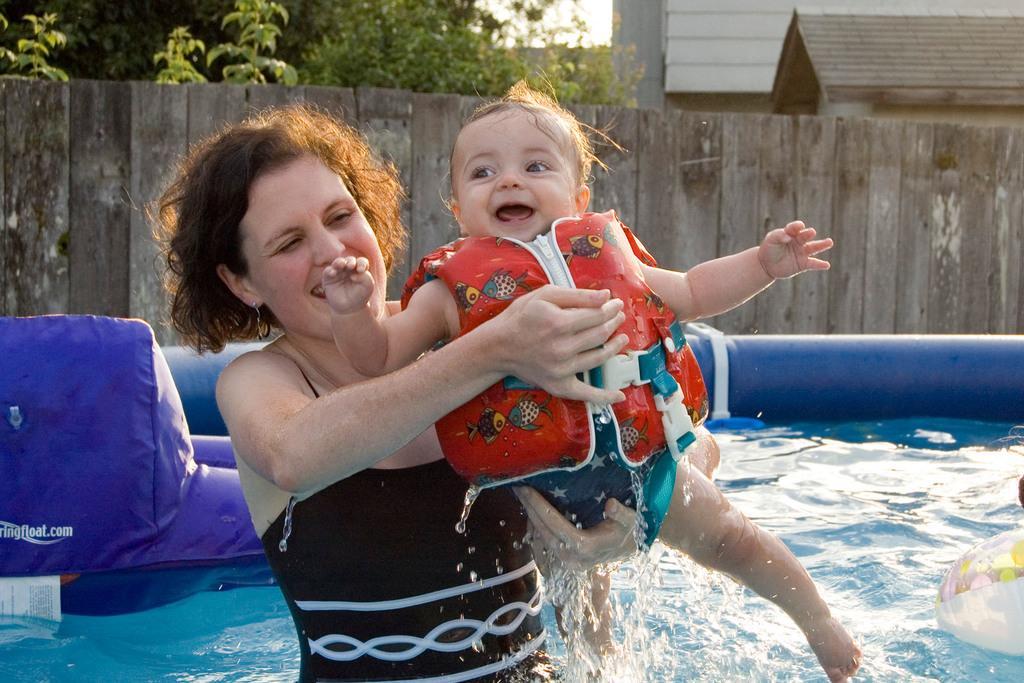Could you give a brief overview of what you see in this image? Here in this picture we can see an inflatable swimming pool, which is filled with water present over a place and in that we can see a woman standing and she is carrying a baby and we can see a jacket on the baby and both of them are smiling and behind them we can see a wooden wall present and behind that we can see other houses present and we can see plants and trees present. 